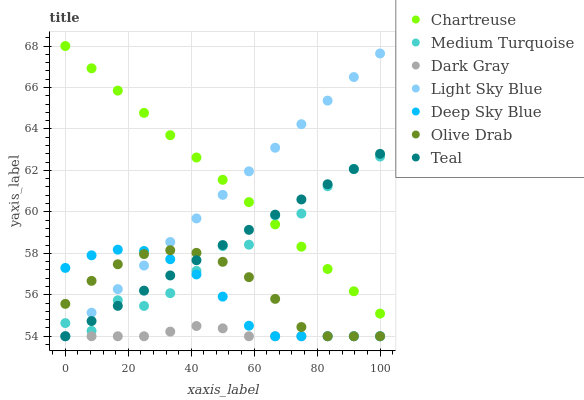Does Dark Gray have the minimum area under the curve?
Answer yes or no. Yes. Does Chartreuse have the maximum area under the curve?
Answer yes or no. Yes. Does Medium Turquoise have the minimum area under the curve?
Answer yes or no. No. Does Medium Turquoise have the maximum area under the curve?
Answer yes or no. No. Is Chartreuse the smoothest?
Answer yes or no. Yes. Is Medium Turquoise the roughest?
Answer yes or no. Yes. Is Dark Gray the smoothest?
Answer yes or no. No. Is Dark Gray the roughest?
Answer yes or no. No. Does Teal have the lowest value?
Answer yes or no. Yes. Does Medium Turquoise have the lowest value?
Answer yes or no. No. Does Chartreuse have the highest value?
Answer yes or no. Yes. Does Medium Turquoise have the highest value?
Answer yes or no. No. Is Dark Gray less than Chartreuse?
Answer yes or no. Yes. Is Medium Turquoise greater than Dark Gray?
Answer yes or no. Yes. Does Teal intersect Medium Turquoise?
Answer yes or no. Yes. Is Teal less than Medium Turquoise?
Answer yes or no. No. Is Teal greater than Medium Turquoise?
Answer yes or no. No. Does Dark Gray intersect Chartreuse?
Answer yes or no. No. 